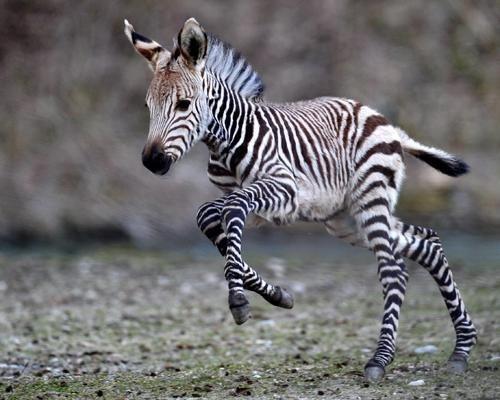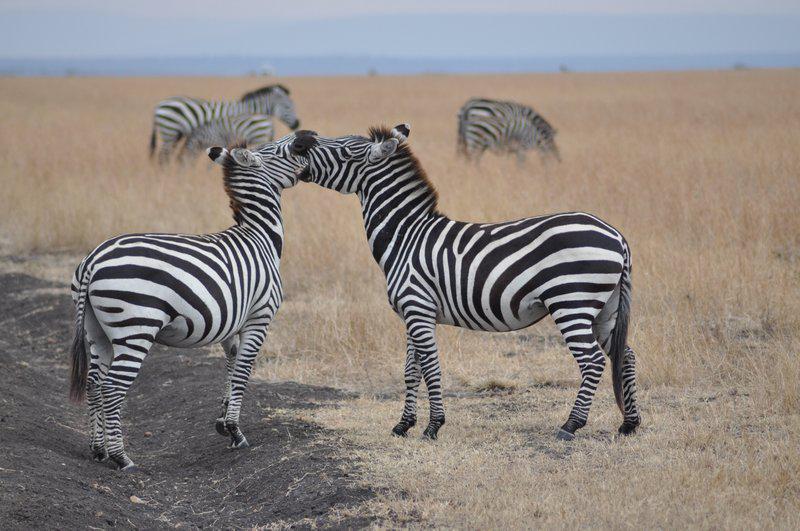The first image is the image on the left, the second image is the image on the right. Considering the images on both sides, is "The left image shows a young zebra bounding leftward, with multiple feet off the ground, and the right image features two zebras fact-to-face." valid? Answer yes or no. Yes. The first image is the image on the left, the second image is the image on the right. Given the left and right images, does the statement "One of the animals in the image on the right only has two feet on the ground." hold true? Answer yes or no. No. 